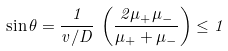<formula> <loc_0><loc_0><loc_500><loc_500>\sin \theta = \frac { 1 } { v / D } \, \left ( \frac { 2 \mu _ { + } \mu _ { - } } { \mu _ { + } + \mu _ { - } } \right ) \leq 1</formula> 